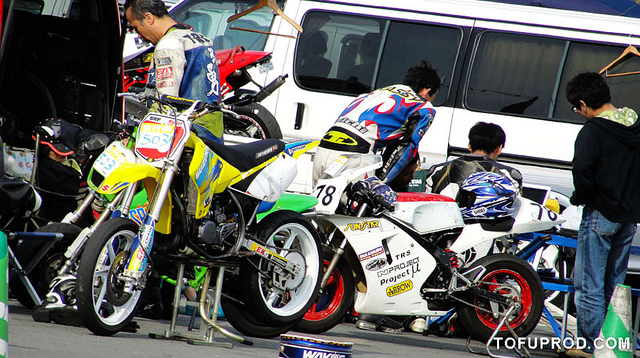<image>How much do those safety helmets weigh? It is unknown how much those safety helmets weigh. They could weigh between 1 and 10 pounds. How much do those safety helmets weigh? I don't know how much those safety helmets weigh. It can be 1 pound, 2 pounds, 3 pounds or even 8 pounds. 